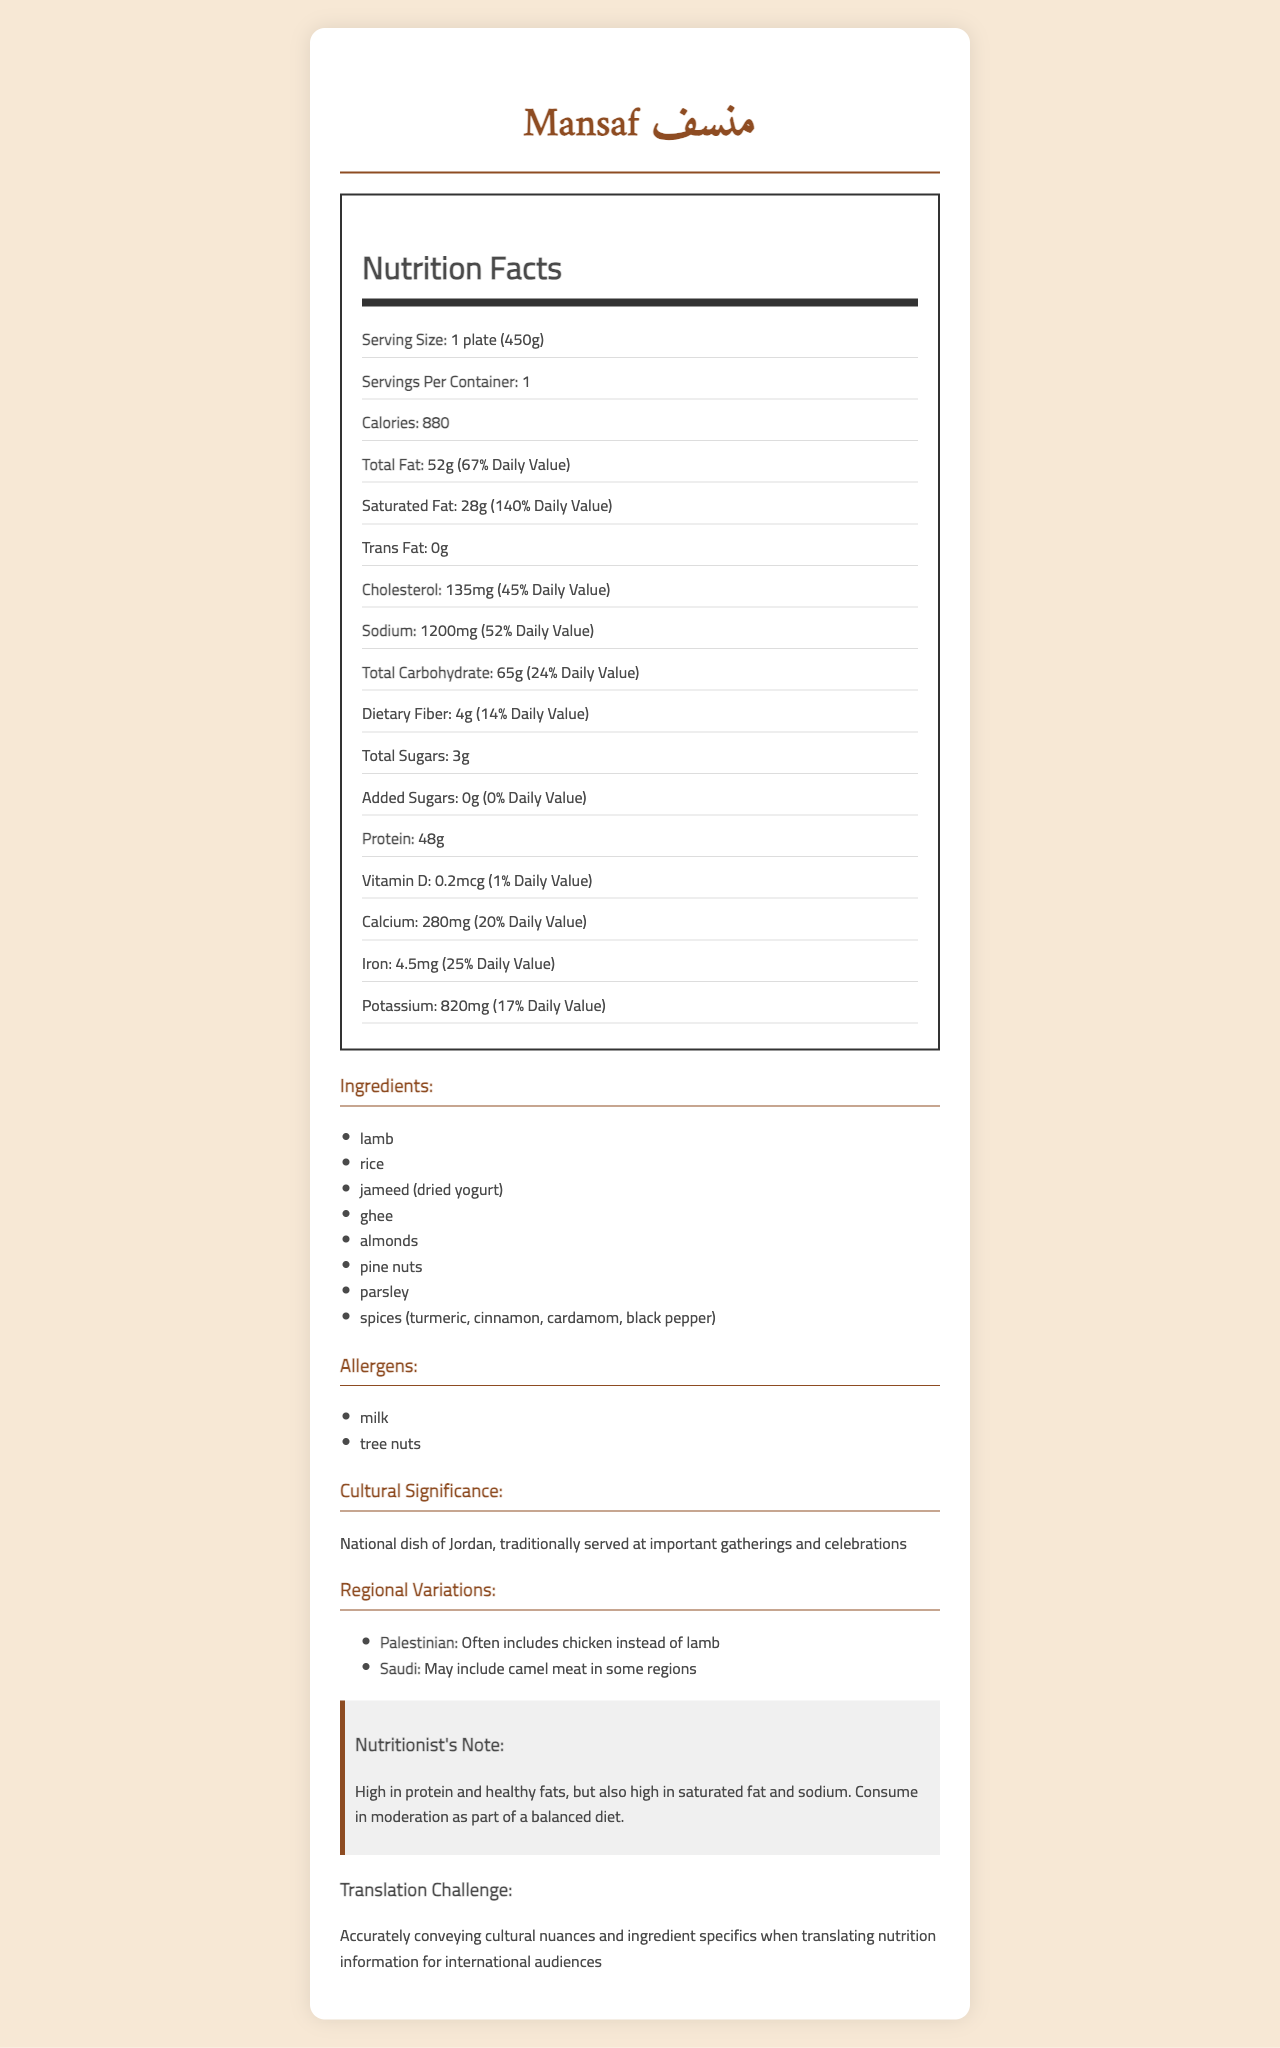what is the serving size of Mansaf? The serving size is explicitly mentioned as "1 plate (450g)" on the document.
Answer: 1 plate (450g) how many calories are in one serving of Mansaf? According to the document, one serving of Mansaf contains 880 calories.
Answer: 880 what is the amount of saturated fat in one serving of Mansaf? The nutrition facts indicate that one serving of Mansaf has 28 grams of saturated fat.
Answer: 28g how much sodium does Mansaf contain per serving? The document specifies that one serving of Mansaf contains 1200 milligrams of sodium.
Answer: 1200mg what are the main ingredients in Mansaf? The listed ingredients in the document include lamb, rice, jameed, ghee, almonds, pine nuts, parsley, and various spices.
Answer: lamb, rice, jameed (dried yogurt), ghee, almonds, pine nuts, parsley, spices (turmeric, cinnamon, cardamom, black pepper) which of the following is not a regional variation of Mansaf? A. Palestinian version with chicken B. Saudi version with camel meat C. Moroccan version with fish The document does not mention a Moroccan version with fish as a regional variation; only Palestinian and Saudi variations are listed.
Answer: C which nutrient has the highest daily value percentage in Mansaf? A. Calcium B. Protein C. Saturated Fat D. Sodium Saturated Fat has a daily value percentage of 140%, which is higher than Calcium, Protein, and Sodium.
Answer: C does Mansaf contain any added sugars? The document states that Mansaf contains 0 grams of added sugars.
Answer: No is Mansaf considered a low-sodium dish? With 1200mg of sodium per serving and 52% of the daily value, Mansaf is not considered a low-sodium dish.
Answer: No describe the cultural significance of Mansaf. The document mentions that Mansaf holds cultural significance as the national dish of Jordan and is traditionally served at important gatherings and celebrations.
Answer: Mansaf is the national dish of Jordan, traditionally served at important gatherings and celebrations. is the amount of protein in Mansaf higher than the amount of total carbohydrate? The document shows that Mansaf has 48 grams of protein and 65 grams of total carbohydrate. While the carbohydrate content is higher in grams, carbohydrates typically aren't compared directly to proteins in terms of higher or lower amounts because they serve different nutritional roles.
Answer: Yes what is challenging about translating the nutrition information of Mansaf? The translation challenge is mentioned as accurately conveying cultural nuances and ingredient specifics when translating nutrition information for international audiences.
Answer: Accurately conveying cultural nuances and ingredient specifics for international audiences what type of cuisine is Mansaf? The document identifies Mansaf as traditional Arabic cuisine.
Answer: Traditional Arabic cuisine summarize the main nutritional content and cultural significance of Mansaf described in the document. The document provides a breakdown of the nutritional content of Mansaf along with its cultural significance as the national dish of Jordan, traditionally served at important gatherings. The main ingredients and some regional variations are also listed in the document.
Answer: Mansaf, the national dish of Jordan, traditionally served at important gatherings and celebrations, is described in the document as having 880 calories per serving (1 plate or 450g). It is rich in protein (48g) but also high in saturated fat (28g) and sodium (1200mg). The main ingredients include lamb, rice, jameed (dried yogurt), and various spices. The dish has regional variations, such as using chicken in the Palestinian version and camel meat in some Saudi regions. what is the exact amount of Vitamin A in Mansaf? The document does not provide any details on the amount of Vitamin A in Mansaf.
Answer: Not enough information 